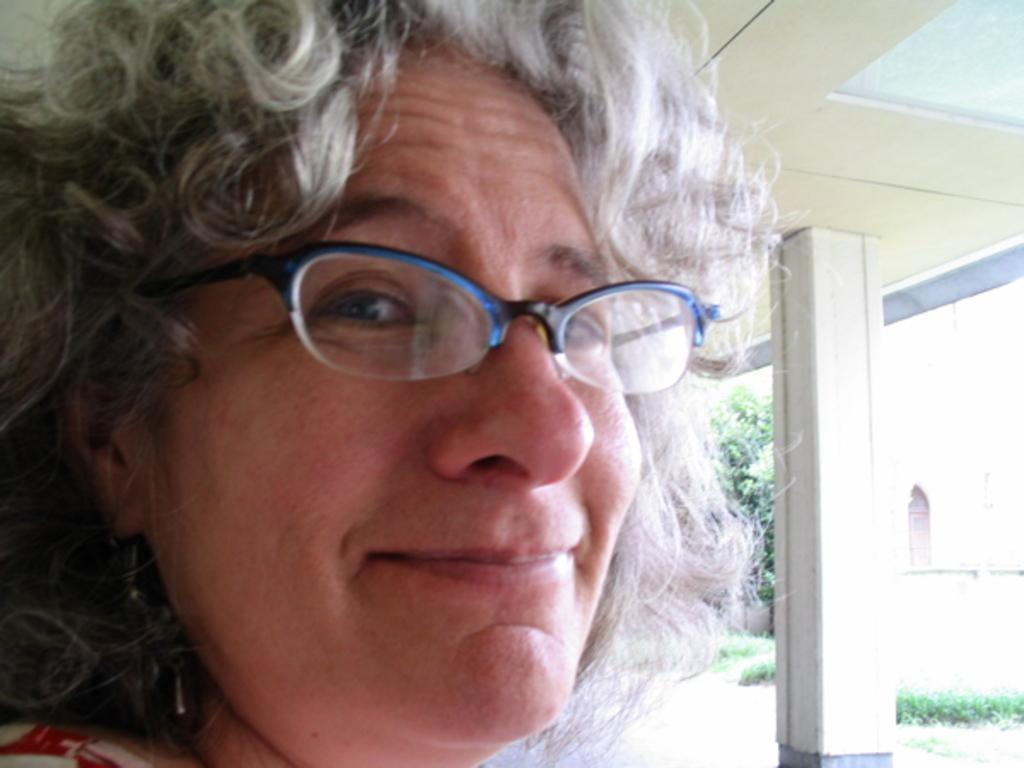Who is present in the image? There is a woman in the image. What architectural feature can be seen in the image? There is a pillar in the image. What type of structure is depicted in the image? There is a roof and walls in the image, suggesting a building or enclosed space. What is the purpose of the pipeline in the image? The purpose of the pipeline is not specified in the image, but it could be for water, gas, or other utilities. What natural elements are present in the image? There is a tree and grass in the image. What date is marked on the calendar in the image? There is no calendar present in the image, so it is not possible to determine the date. 